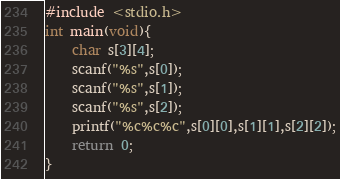Convert code to text. <code><loc_0><loc_0><loc_500><loc_500><_C_>#include <stdio.h>
int main(void){
	char s[3][4];
	scanf("%s",s[0]);
	scanf("%s",s[1]);
	scanf("%s",s[2]);
	printf("%c%c%c",s[0][0],s[1][1],s[2][2]);
	return 0;
}</code> 